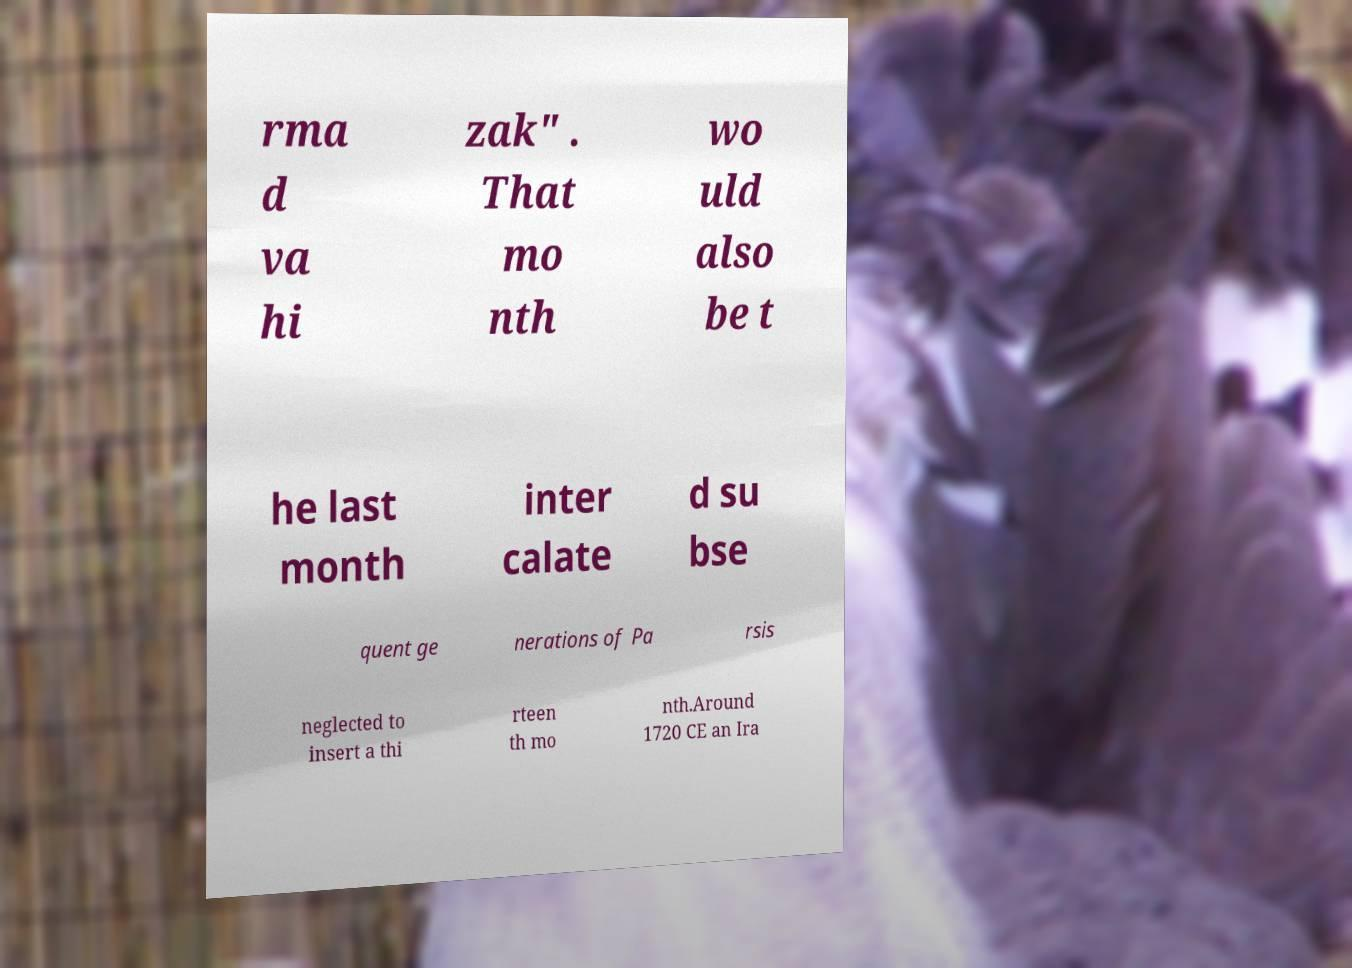For documentation purposes, I need the text within this image transcribed. Could you provide that? rma d va hi zak" . That mo nth wo uld also be t he last month inter calate d su bse quent ge nerations of Pa rsis neglected to insert a thi rteen th mo nth.Around 1720 CE an Ira 